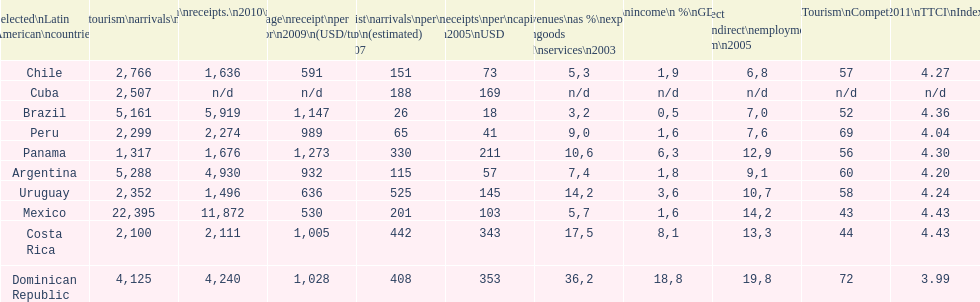Which latin american country had the largest number of tourism arrivals in 2010? Mexico. 